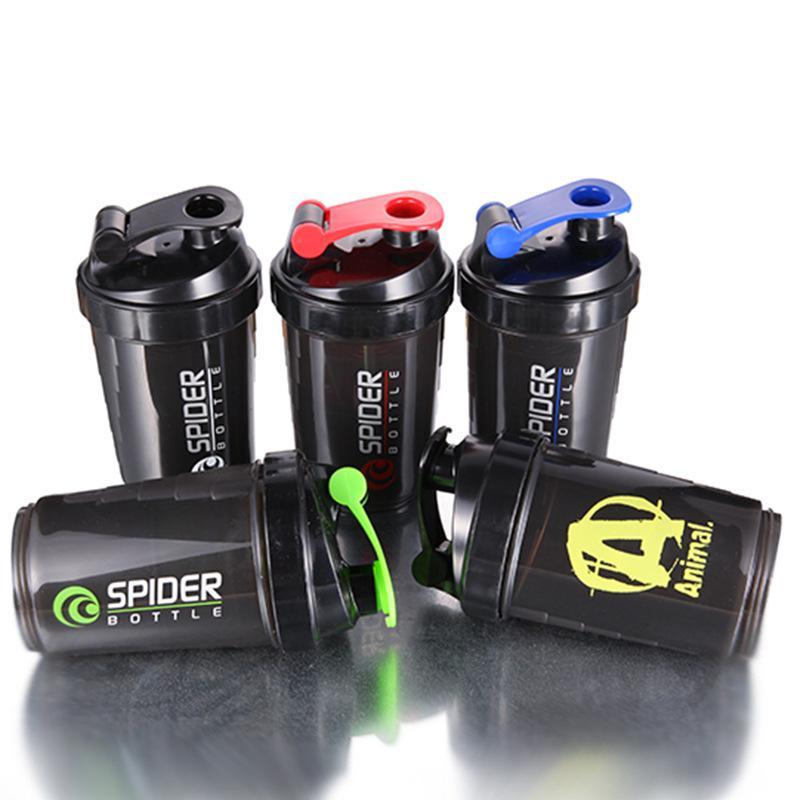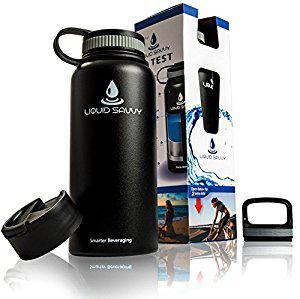The first image is the image on the left, the second image is the image on the right. Analyze the images presented: Is the assertion "in the image on the left, there is at least 3 containers visible." valid? Answer yes or no. Yes. The first image is the image on the left, the second image is the image on the right. Evaluate the accuracy of this statement regarding the images: "There is a total of 1 pouch that holds 3 plastic bottles.". Is it true? Answer yes or no. No. 